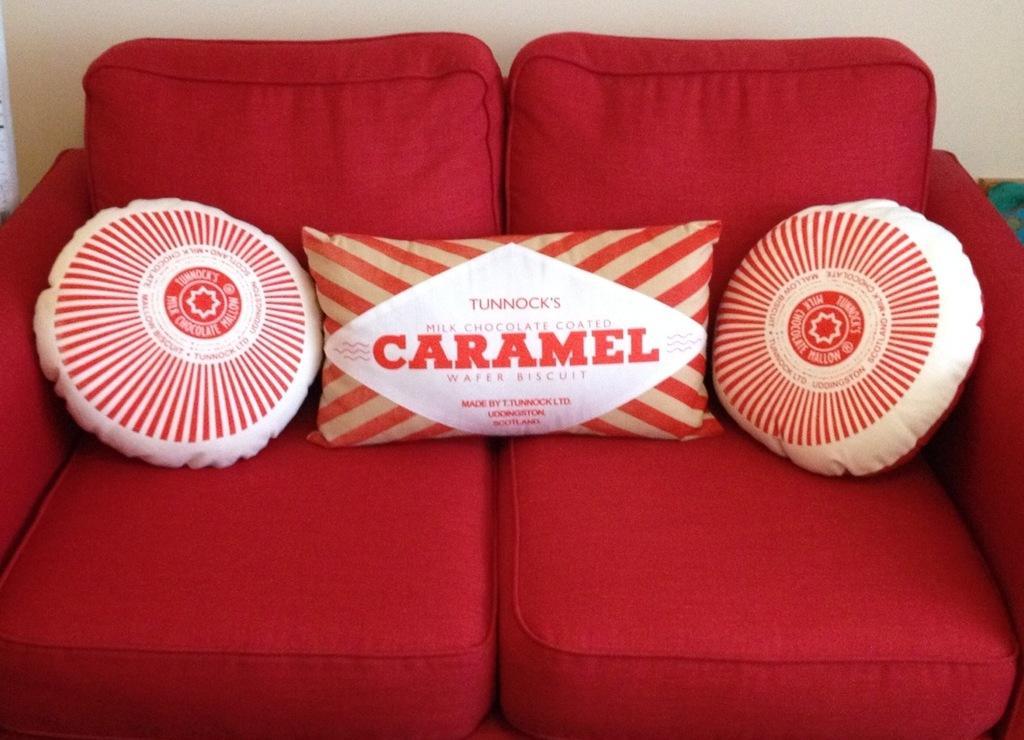Can you describe this image briefly? In the image there is red color sofa with three pillows on it and behind it there is wall. 